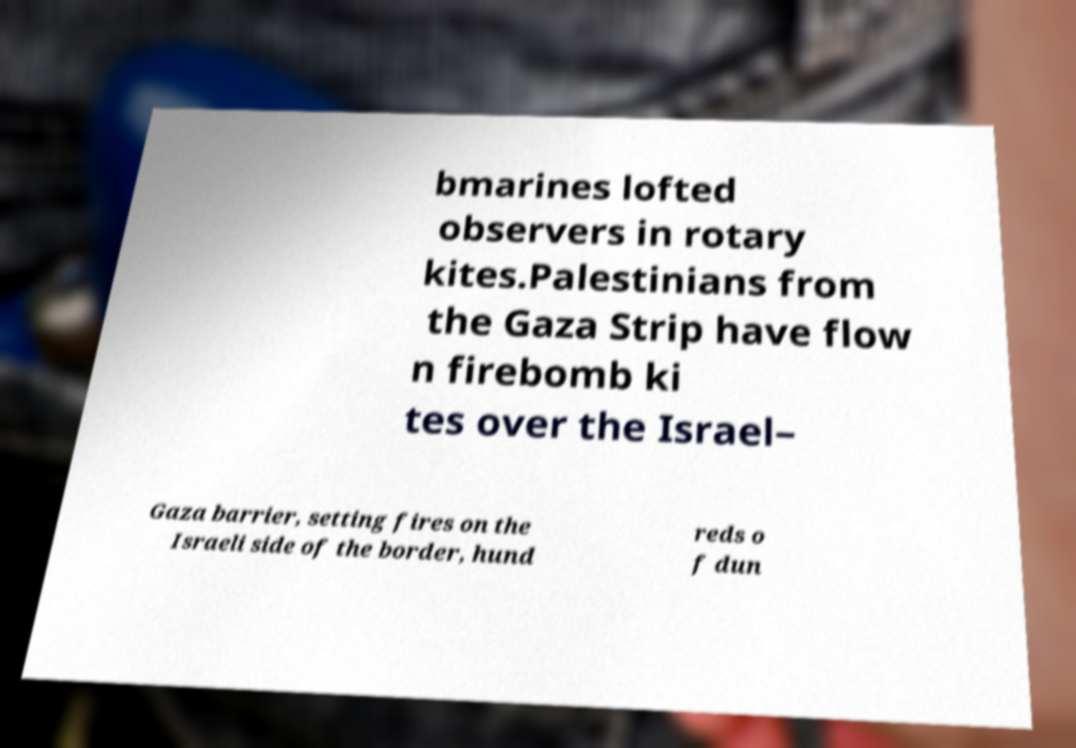Please identify and transcribe the text found in this image. bmarines lofted observers in rotary kites.Palestinians from the Gaza Strip have flow n firebomb ki tes over the Israel– Gaza barrier, setting fires on the Israeli side of the border, hund reds o f dun 